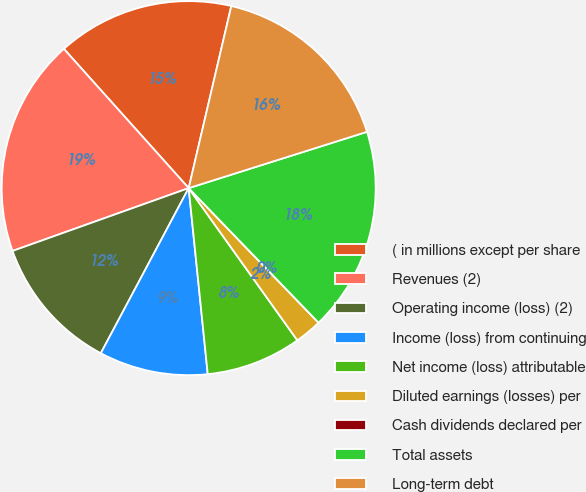<chart> <loc_0><loc_0><loc_500><loc_500><pie_chart><fcel>( in millions except per share<fcel>Revenues (2)<fcel>Operating income (loss) (2)<fcel>Income (loss) from continuing<fcel>Net income (loss) attributable<fcel>Diluted earnings (losses) per<fcel>Cash dividends declared per<fcel>Total assets<fcel>Long-term debt<nl><fcel>15.29%<fcel>18.82%<fcel>11.76%<fcel>9.41%<fcel>8.24%<fcel>2.35%<fcel>0.0%<fcel>17.65%<fcel>16.47%<nl></chart> 